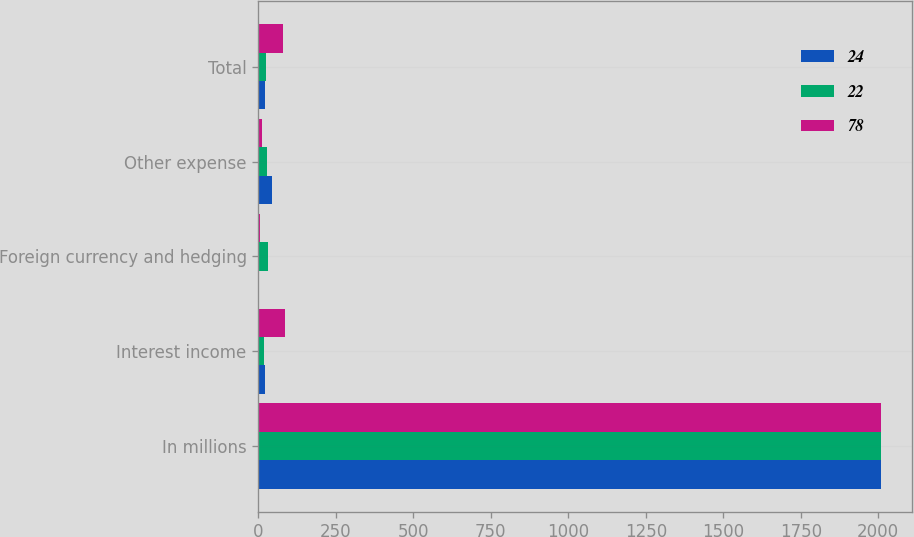Convert chart to OTSL. <chart><loc_0><loc_0><loc_500><loc_500><stacked_bar_chart><ecel><fcel>In millions<fcel>Interest income<fcel>Foreign currency and hedging<fcel>Other expense<fcel>Total<nl><fcel>24<fcel>2010<fcel>20<fcel>2<fcel>44<fcel>22<nl><fcel>22<fcel>2009<fcel>19<fcel>32<fcel>27<fcel>24<nl><fcel>78<fcel>2008<fcel>85<fcel>5<fcel>12<fcel>78<nl></chart> 